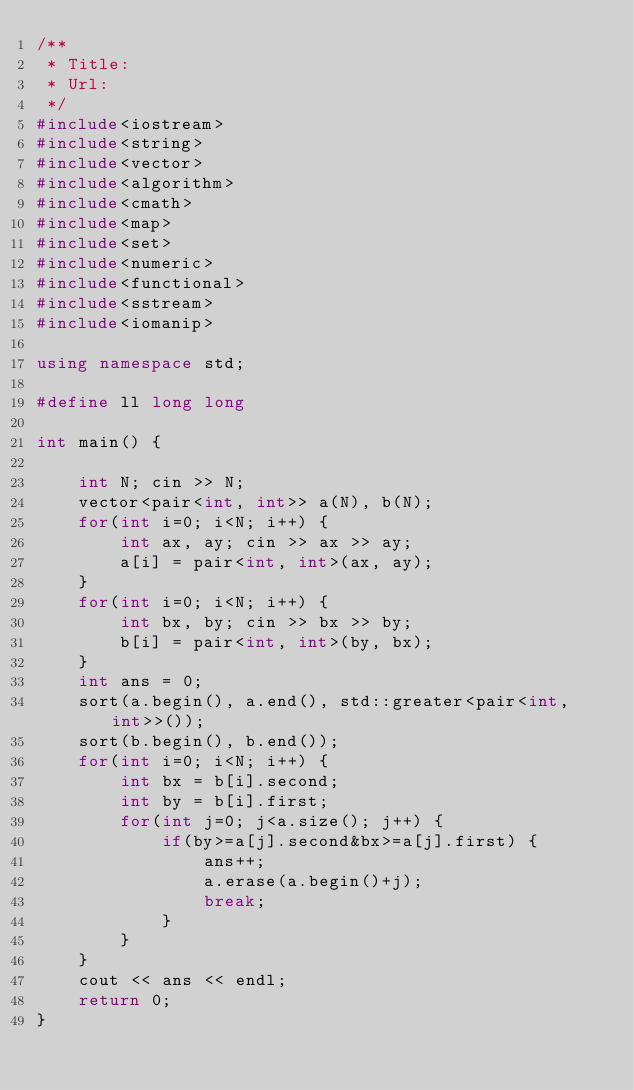Convert code to text. <code><loc_0><loc_0><loc_500><loc_500><_C++_>/**
 * Title:
 * Url:
 */
#include<iostream>
#include<string>
#include<vector>
#include<algorithm>
#include<cmath>
#include<map>
#include<set>
#include<numeric>
#include<functional>
#include<sstream>
#include<iomanip>

using namespace std;

#define ll long long

int main() {

    int N; cin >> N;
    vector<pair<int, int>> a(N), b(N);
    for(int i=0; i<N; i++) {
        int ax, ay; cin >> ax >> ay;
        a[i] = pair<int, int>(ax, ay);
    }
    for(int i=0; i<N; i++) {
        int bx, by; cin >> bx >> by;
        b[i] = pair<int, int>(by, bx);
    }
    int ans = 0;
    sort(a.begin(), a.end(), std::greater<pair<int, int>>());
    sort(b.begin(), b.end());
    for(int i=0; i<N; i++) {
        int bx = b[i].second;
        int by = b[i].first;
        for(int j=0; j<a.size(); j++) {
            if(by>=a[j].second&bx>=a[j].first) {
                ans++;
                a.erase(a.begin()+j);
                break;
            }
        }
    }
    cout << ans << endl;
    return 0;
}</code> 